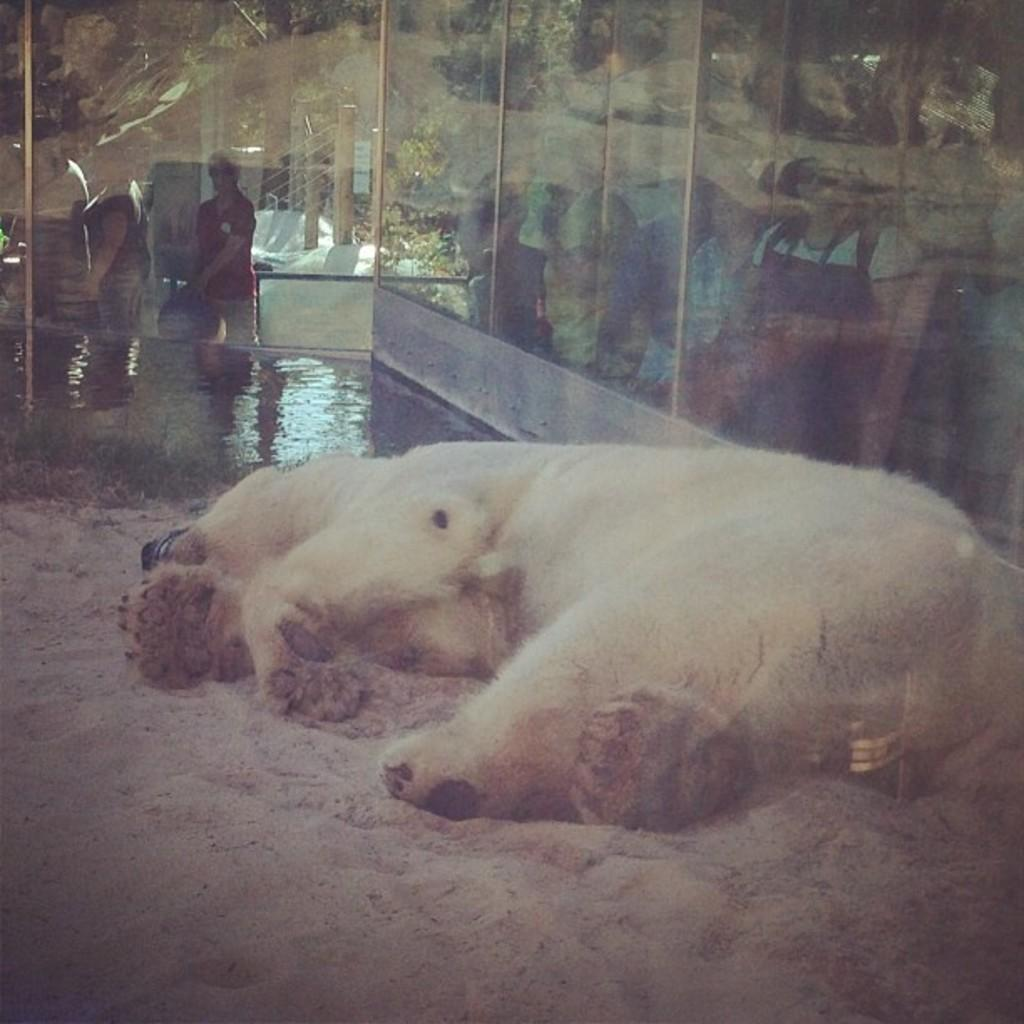What type of animal can be seen in the image? There is a white animal in the image. What is the position of the animal in the image? The animal is lying on the ground. What can be seen in the background of the image? Water is visible in the background of the image. What are the people doing in the background of the image? People are standing behind a glass wall in the background of the image. How many ducks are swimming in the water in the image? There are no ducks present in the image. 